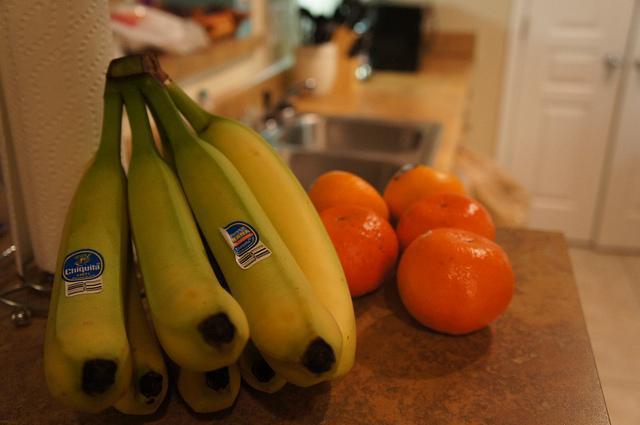Is the caption "The dining table is touching the banana." a true representation of the image?
Answer yes or no. Yes. 